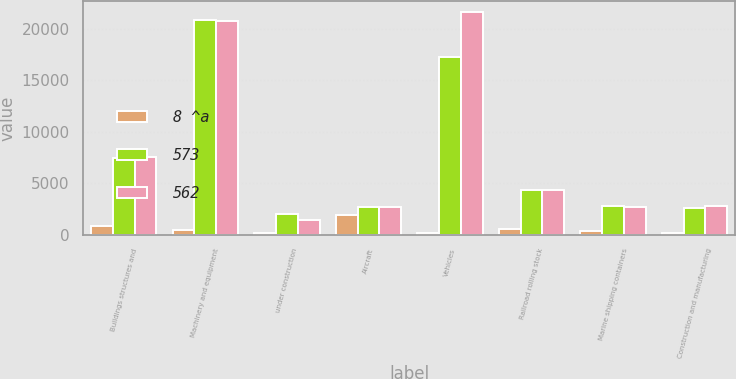Convert chart. <chart><loc_0><loc_0><loc_500><loc_500><stacked_bar_chart><ecel><fcel>Buildings structures and<fcel>Machinery and equipment<fcel>under construction<fcel>Aircraft<fcel>Vehicles<fcel>Railroad rolling stock<fcel>Marine shipping containers<fcel>Construction and manufacturing<nl><fcel>8 ^a<fcel>840<fcel>420<fcel>110<fcel>1921<fcel>123<fcel>550<fcel>330<fcel>130<nl><fcel>573<fcel>7468<fcel>20833<fcel>1986<fcel>2656.5<fcel>17216<fcel>4331<fcel>2748<fcel>2586<nl><fcel>562<fcel>7569<fcel>20714<fcel>1431<fcel>2656.5<fcel>21589<fcel>4290<fcel>2727<fcel>2759<nl></chart> 